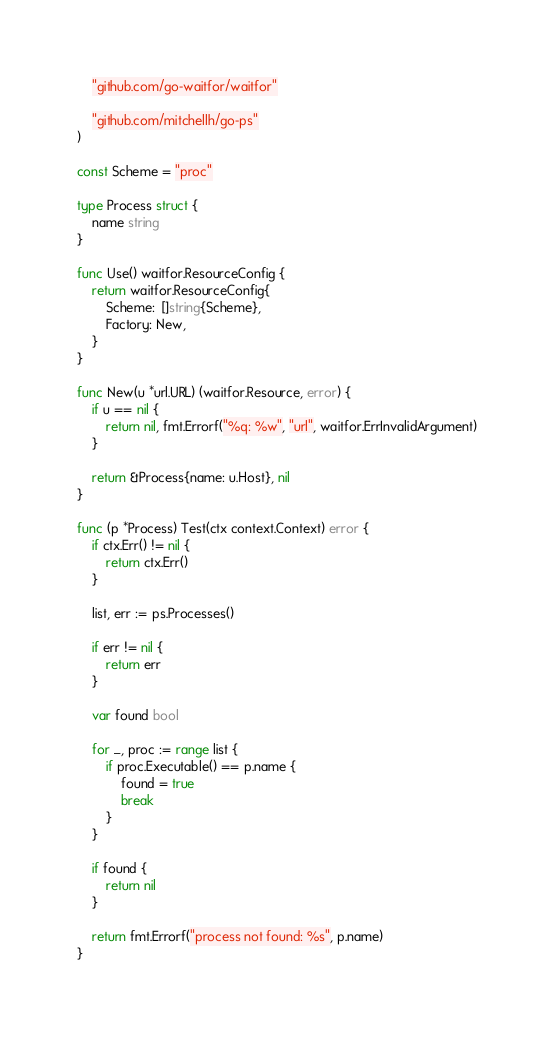<code> <loc_0><loc_0><loc_500><loc_500><_Go_>	"github.com/go-waitfor/waitfor"

	"github.com/mitchellh/go-ps"
)

const Scheme = "proc"

type Process struct {
	name string
}

func Use() waitfor.ResourceConfig {
	return waitfor.ResourceConfig{
		Scheme:  []string{Scheme},
		Factory: New,
	}
}

func New(u *url.URL) (waitfor.Resource, error) {
	if u == nil {
		return nil, fmt.Errorf("%q: %w", "url", waitfor.ErrInvalidArgument)
	}

	return &Process{name: u.Host}, nil
}

func (p *Process) Test(ctx context.Context) error {
	if ctx.Err() != nil {
		return ctx.Err()
	}

	list, err := ps.Processes()

	if err != nil {
		return err
	}

	var found bool

	for _, proc := range list {
		if proc.Executable() == p.name {
			found = true
			break
		}
	}

	if found {
		return nil
	}

	return fmt.Errorf("process not found: %s", p.name)
}
</code> 